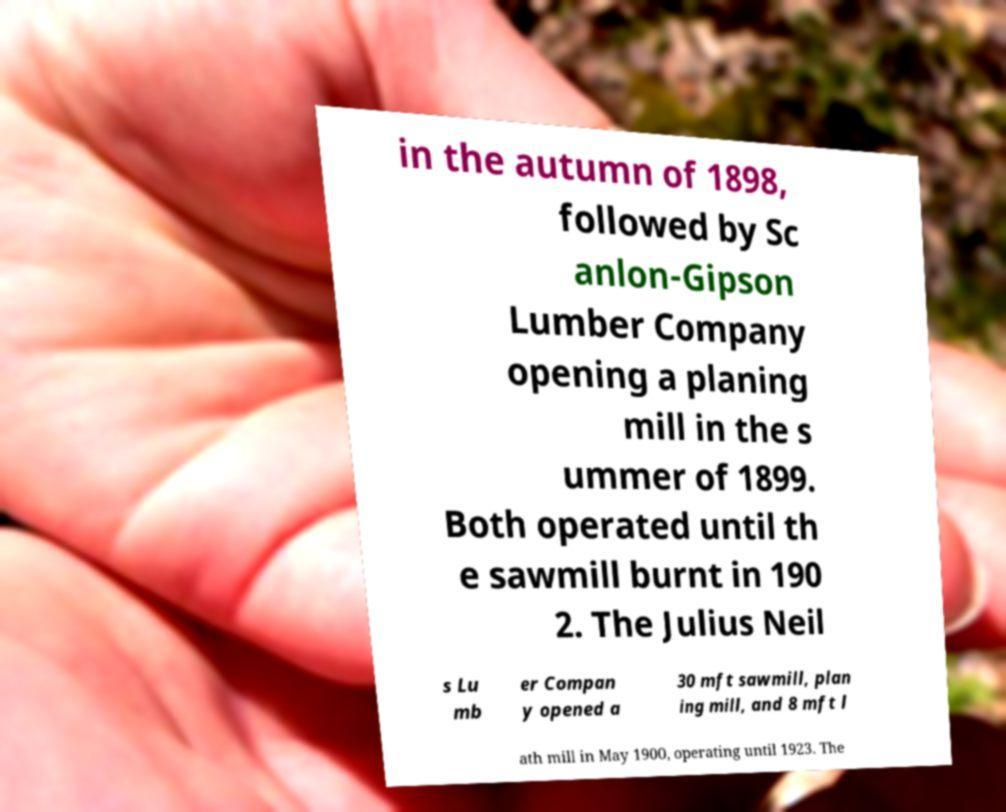What messages or text are displayed in this image? I need them in a readable, typed format. in the autumn of 1898, followed by Sc anlon-Gipson Lumber Company opening a planing mill in the s ummer of 1899. Both operated until th e sawmill burnt in 190 2. The Julius Neil s Lu mb er Compan y opened a 30 mft sawmill, plan ing mill, and 8 mft l ath mill in May 1900, operating until 1923. The 